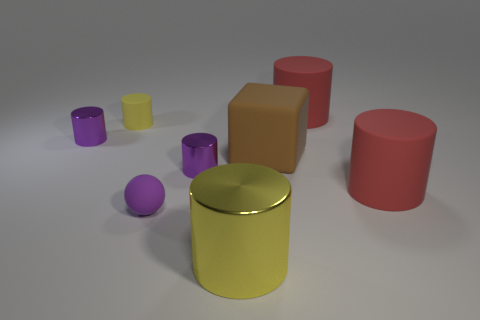Can you describe the texture of the objects? The objects in the image appear to have a smooth, matte texture, without any visible roughness or glossiness. 